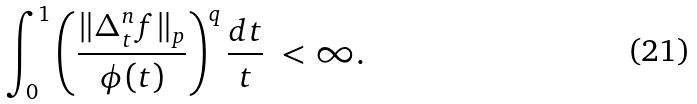Convert formula to latex. <formula><loc_0><loc_0><loc_500><loc_500>\int _ { 0 } ^ { 1 } \left ( \frac { \| \Delta ^ { n } _ { t } f \| _ { p } } { \phi ( t ) } \right ) ^ { q } \frac { d t } { t } \ < \infty .</formula> 